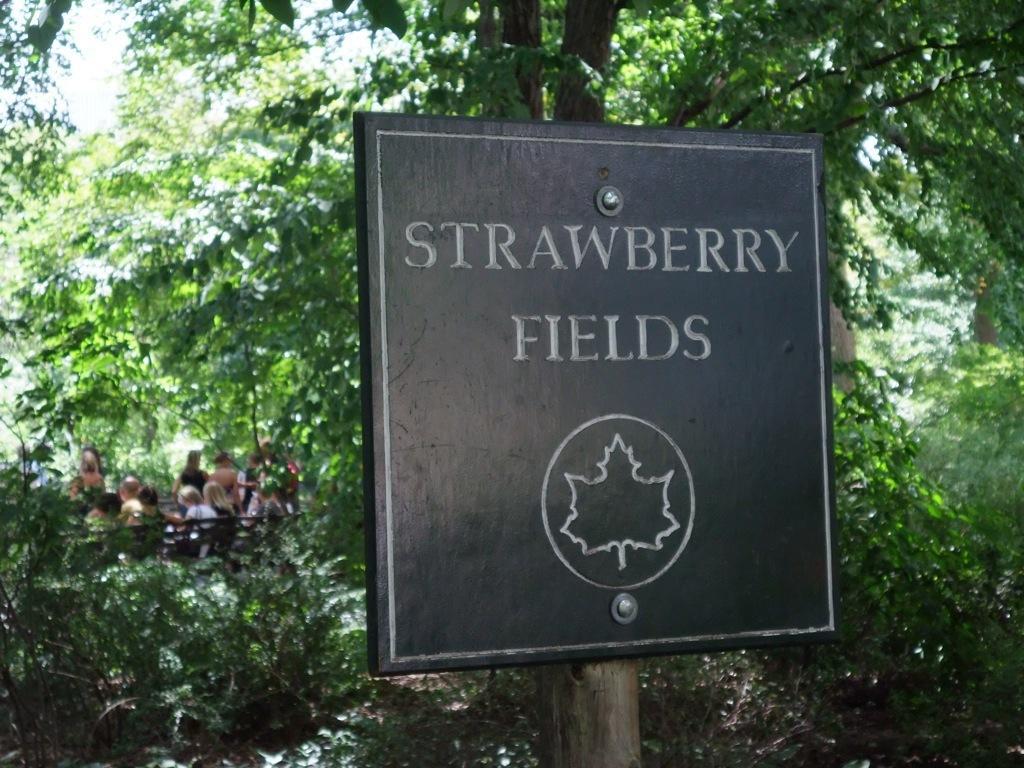Please provide a concise description of this image. In the middle of the image we can see a noticeboard, in the background we can find few trees and group of people, few are seated on the bench and few are standing. 